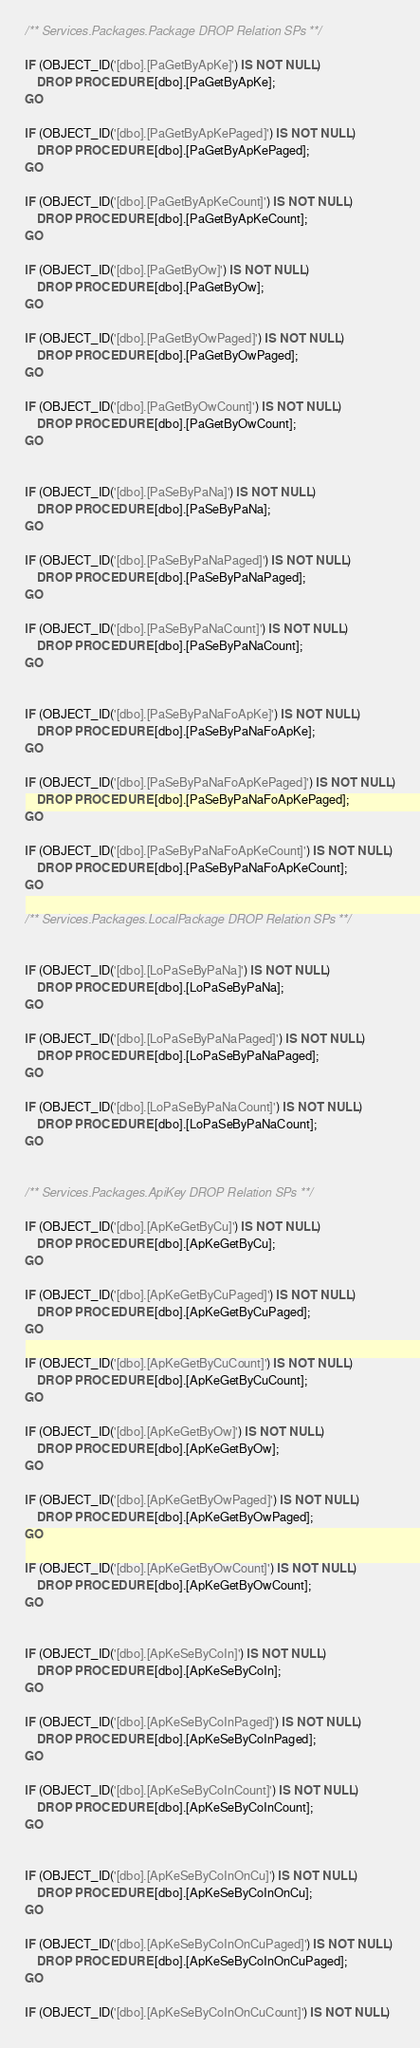<code> <loc_0><loc_0><loc_500><loc_500><_SQL_>/** Services.Packages.Package DROP Relation SPs **/

IF (OBJECT_ID('[dbo].[PaGetByApKe]') IS NOT NULL)
	DROP PROCEDURE [dbo].[PaGetByApKe];
GO

IF (OBJECT_ID('[dbo].[PaGetByApKePaged]') IS NOT NULL)
	DROP PROCEDURE [dbo].[PaGetByApKePaged];
GO

IF (OBJECT_ID('[dbo].[PaGetByApKeCount]') IS NOT NULL)
	DROP PROCEDURE [dbo].[PaGetByApKeCount];
GO

IF (OBJECT_ID('[dbo].[PaGetByOw]') IS NOT NULL)
	DROP PROCEDURE [dbo].[PaGetByOw];
GO

IF (OBJECT_ID('[dbo].[PaGetByOwPaged]') IS NOT NULL)
	DROP PROCEDURE [dbo].[PaGetByOwPaged];
GO

IF (OBJECT_ID('[dbo].[PaGetByOwCount]') IS NOT NULL)
	DROP PROCEDURE [dbo].[PaGetByOwCount];
GO


IF (OBJECT_ID('[dbo].[PaSeByPaNa]') IS NOT NULL)
	DROP PROCEDURE [dbo].[PaSeByPaNa];
GO

IF (OBJECT_ID('[dbo].[PaSeByPaNaPaged]') IS NOT NULL)
	DROP PROCEDURE [dbo].[PaSeByPaNaPaged];
GO

IF (OBJECT_ID('[dbo].[PaSeByPaNaCount]') IS NOT NULL)
	DROP PROCEDURE [dbo].[PaSeByPaNaCount];
GO


IF (OBJECT_ID('[dbo].[PaSeByPaNaFoApKe]') IS NOT NULL)
	DROP PROCEDURE [dbo].[PaSeByPaNaFoApKe];
GO

IF (OBJECT_ID('[dbo].[PaSeByPaNaFoApKePaged]') IS NOT NULL)
	DROP PROCEDURE [dbo].[PaSeByPaNaFoApKePaged];
GO

IF (OBJECT_ID('[dbo].[PaSeByPaNaFoApKeCount]') IS NOT NULL)
	DROP PROCEDURE [dbo].[PaSeByPaNaFoApKeCount];
GO

/** Services.Packages.LocalPackage DROP Relation SPs **/


IF (OBJECT_ID('[dbo].[LoPaSeByPaNa]') IS NOT NULL)
	DROP PROCEDURE [dbo].[LoPaSeByPaNa];
GO

IF (OBJECT_ID('[dbo].[LoPaSeByPaNaPaged]') IS NOT NULL)
	DROP PROCEDURE [dbo].[LoPaSeByPaNaPaged];
GO

IF (OBJECT_ID('[dbo].[LoPaSeByPaNaCount]') IS NOT NULL)
	DROP PROCEDURE [dbo].[LoPaSeByPaNaCount];
GO


/** Services.Packages.ApiKey DROP Relation SPs **/

IF (OBJECT_ID('[dbo].[ApKeGetByCu]') IS NOT NULL)
	DROP PROCEDURE [dbo].[ApKeGetByCu];
GO

IF (OBJECT_ID('[dbo].[ApKeGetByCuPaged]') IS NOT NULL)
	DROP PROCEDURE [dbo].[ApKeGetByCuPaged];
GO

IF (OBJECT_ID('[dbo].[ApKeGetByCuCount]') IS NOT NULL)
	DROP PROCEDURE [dbo].[ApKeGetByCuCount];
GO

IF (OBJECT_ID('[dbo].[ApKeGetByOw]') IS NOT NULL)
	DROP PROCEDURE [dbo].[ApKeGetByOw];
GO

IF (OBJECT_ID('[dbo].[ApKeGetByOwPaged]') IS NOT NULL)
	DROP PROCEDURE [dbo].[ApKeGetByOwPaged];
GO

IF (OBJECT_ID('[dbo].[ApKeGetByOwCount]') IS NOT NULL)
	DROP PROCEDURE [dbo].[ApKeGetByOwCount];
GO


IF (OBJECT_ID('[dbo].[ApKeSeByCoIn]') IS NOT NULL)
	DROP PROCEDURE [dbo].[ApKeSeByCoIn];
GO

IF (OBJECT_ID('[dbo].[ApKeSeByCoInPaged]') IS NOT NULL)
	DROP PROCEDURE [dbo].[ApKeSeByCoInPaged];
GO

IF (OBJECT_ID('[dbo].[ApKeSeByCoInCount]') IS NOT NULL)
	DROP PROCEDURE [dbo].[ApKeSeByCoInCount];
GO


IF (OBJECT_ID('[dbo].[ApKeSeByCoInOnCu]') IS NOT NULL)
	DROP PROCEDURE [dbo].[ApKeSeByCoInOnCu];
GO

IF (OBJECT_ID('[dbo].[ApKeSeByCoInOnCuPaged]') IS NOT NULL)
	DROP PROCEDURE [dbo].[ApKeSeByCoInOnCuPaged];
GO

IF (OBJECT_ID('[dbo].[ApKeSeByCoInOnCuCount]') IS NOT NULL)</code> 